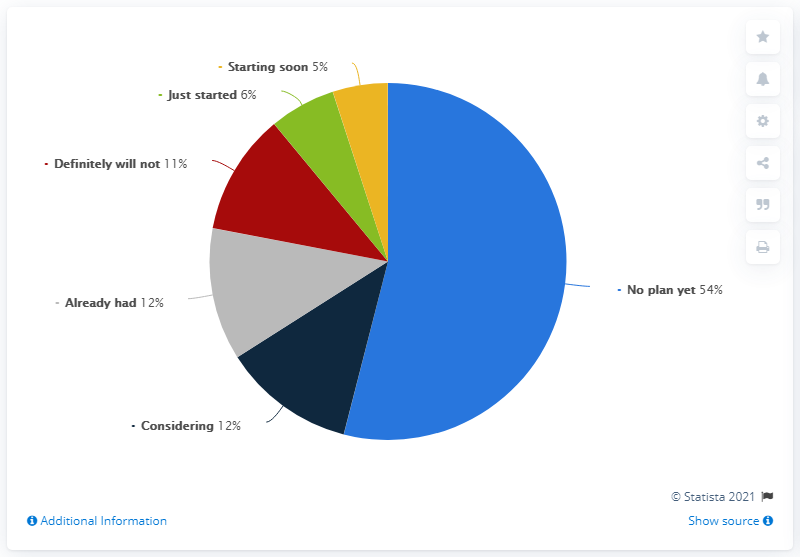Draw attention to some important aspects in this diagram. There are a total of 6 colored segments. The percentage of companies that currently offer remote work is approximately 21.95%, while the percentage of companies that do not offer remote work is approximately 78.05%. 